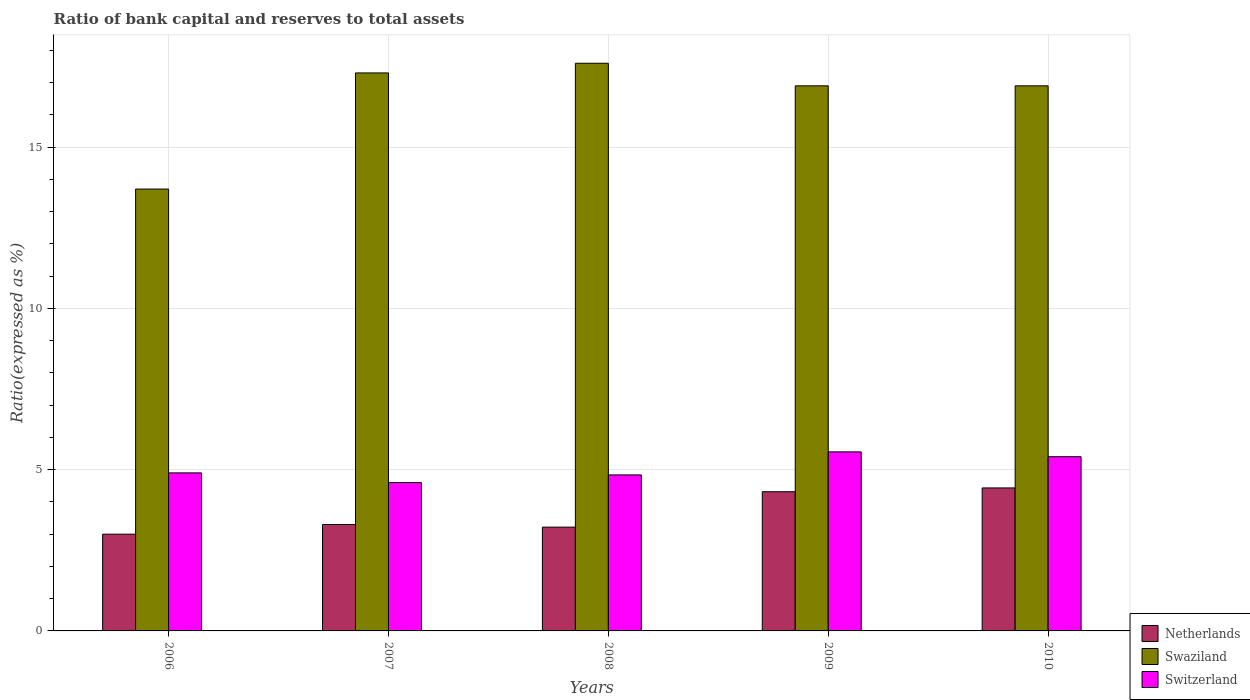Are the number of bars per tick equal to the number of legend labels?
Your answer should be compact. Yes. Are the number of bars on each tick of the X-axis equal?
Offer a terse response. Yes. What is the ratio of bank capital and reserves to total assets in Switzerland in 2008?
Ensure brevity in your answer.  4.84. Across all years, what is the maximum ratio of bank capital and reserves to total assets in Netherlands?
Provide a short and direct response. 4.43. Across all years, what is the minimum ratio of bank capital and reserves to total assets in Switzerland?
Keep it short and to the point. 4.6. In which year was the ratio of bank capital and reserves to total assets in Switzerland maximum?
Provide a succinct answer. 2009. In which year was the ratio of bank capital and reserves to total assets in Swaziland minimum?
Provide a short and direct response. 2006. What is the total ratio of bank capital and reserves to total assets in Swaziland in the graph?
Offer a very short reply. 82.4. What is the difference between the ratio of bank capital and reserves to total assets in Swaziland in 2008 and that in 2010?
Ensure brevity in your answer.  0.7. What is the difference between the ratio of bank capital and reserves to total assets in Switzerland in 2007 and the ratio of bank capital and reserves to total assets in Netherlands in 2006?
Give a very brief answer. 1.6. What is the average ratio of bank capital and reserves to total assets in Switzerland per year?
Your answer should be compact. 5.06. In the year 2009, what is the difference between the ratio of bank capital and reserves to total assets in Netherlands and ratio of bank capital and reserves to total assets in Switzerland?
Keep it short and to the point. -1.24. In how many years, is the ratio of bank capital and reserves to total assets in Netherlands greater than 4 %?
Your answer should be compact. 2. What is the ratio of the ratio of bank capital and reserves to total assets in Swaziland in 2007 to that in 2010?
Ensure brevity in your answer.  1.02. Is the ratio of bank capital and reserves to total assets in Netherlands in 2007 less than that in 2010?
Provide a short and direct response. Yes. What is the difference between the highest and the second highest ratio of bank capital and reserves to total assets in Swaziland?
Your answer should be very brief. 0.3. What is the difference between the highest and the lowest ratio of bank capital and reserves to total assets in Netherlands?
Ensure brevity in your answer.  1.43. Is the sum of the ratio of bank capital and reserves to total assets in Netherlands in 2009 and 2010 greater than the maximum ratio of bank capital and reserves to total assets in Switzerland across all years?
Provide a short and direct response. Yes. What does the 1st bar from the left in 2006 represents?
Your answer should be compact. Netherlands. What does the 2nd bar from the right in 2010 represents?
Provide a short and direct response. Swaziland. Is it the case that in every year, the sum of the ratio of bank capital and reserves to total assets in Switzerland and ratio of bank capital and reserves to total assets in Swaziland is greater than the ratio of bank capital and reserves to total assets in Netherlands?
Your answer should be compact. Yes. How many bars are there?
Provide a short and direct response. 15. Are the values on the major ticks of Y-axis written in scientific E-notation?
Offer a terse response. No. Does the graph contain grids?
Offer a very short reply. Yes. Where does the legend appear in the graph?
Offer a terse response. Bottom right. What is the title of the graph?
Keep it short and to the point. Ratio of bank capital and reserves to total assets. Does "Central African Republic" appear as one of the legend labels in the graph?
Offer a terse response. No. What is the label or title of the Y-axis?
Offer a very short reply. Ratio(expressed as %). What is the Ratio(expressed as %) in Swaziland in 2007?
Your response must be concise. 17.3. What is the Ratio(expressed as %) in Netherlands in 2008?
Your answer should be compact. 3.22. What is the Ratio(expressed as %) of Swaziland in 2008?
Keep it short and to the point. 17.6. What is the Ratio(expressed as %) of Switzerland in 2008?
Offer a very short reply. 4.84. What is the Ratio(expressed as %) of Netherlands in 2009?
Provide a succinct answer. 4.32. What is the Ratio(expressed as %) in Swaziland in 2009?
Offer a terse response. 16.9. What is the Ratio(expressed as %) in Switzerland in 2009?
Your answer should be very brief. 5.55. What is the Ratio(expressed as %) in Netherlands in 2010?
Provide a succinct answer. 4.43. What is the Ratio(expressed as %) of Switzerland in 2010?
Provide a succinct answer. 5.4. Across all years, what is the maximum Ratio(expressed as %) of Netherlands?
Your answer should be very brief. 4.43. Across all years, what is the maximum Ratio(expressed as %) in Switzerland?
Provide a short and direct response. 5.55. Across all years, what is the minimum Ratio(expressed as %) in Netherlands?
Your answer should be very brief. 3. What is the total Ratio(expressed as %) of Netherlands in the graph?
Offer a very short reply. 18.27. What is the total Ratio(expressed as %) of Swaziland in the graph?
Keep it short and to the point. 82.4. What is the total Ratio(expressed as %) in Switzerland in the graph?
Provide a succinct answer. 25.29. What is the difference between the Ratio(expressed as %) in Netherlands in 2006 and that in 2007?
Your answer should be compact. -0.3. What is the difference between the Ratio(expressed as %) in Netherlands in 2006 and that in 2008?
Your response must be concise. -0.22. What is the difference between the Ratio(expressed as %) in Switzerland in 2006 and that in 2008?
Your answer should be compact. 0.06. What is the difference between the Ratio(expressed as %) of Netherlands in 2006 and that in 2009?
Your answer should be compact. -1.32. What is the difference between the Ratio(expressed as %) in Switzerland in 2006 and that in 2009?
Offer a very short reply. -0.65. What is the difference between the Ratio(expressed as %) of Netherlands in 2006 and that in 2010?
Give a very brief answer. -1.43. What is the difference between the Ratio(expressed as %) of Switzerland in 2006 and that in 2010?
Your answer should be compact. -0.5. What is the difference between the Ratio(expressed as %) in Netherlands in 2007 and that in 2008?
Your response must be concise. 0.08. What is the difference between the Ratio(expressed as %) of Switzerland in 2007 and that in 2008?
Your answer should be compact. -0.24. What is the difference between the Ratio(expressed as %) of Netherlands in 2007 and that in 2009?
Offer a very short reply. -1.02. What is the difference between the Ratio(expressed as %) of Switzerland in 2007 and that in 2009?
Provide a succinct answer. -0.95. What is the difference between the Ratio(expressed as %) in Netherlands in 2007 and that in 2010?
Your answer should be compact. -1.13. What is the difference between the Ratio(expressed as %) in Switzerland in 2007 and that in 2010?
Give a very brief answer. -0.8. What is the difference between the Ratio(expressed as %) of Netherlands in 2008 and that in 2009?
Your answer should be very brief. -1.1. What is the difference between the Ratio(expressed as %) in Switzerland in 2008 and that in 2009?
Provide a succinct answer. -0.71. What is the difference between the Ratio(expressed as %) of Netherlands in 2008 and that in 2010?
Your response must be concise. -1.22. What is the difference between the Ratio(expressed as %) of Swaziland in 2008 and that in 2010?
Your response must be concise. 0.7. What is the difference between the Ratio(expressed as %) of Switzerland in 2008 and that in 2010?
Offer a very short reply. -0.56. What is the difference between the Ratio(expressed as %) of Netherlands in 2009 and that in 2010?
Offer a very short reply. -0.12. What is the difference between the Ratio(expressed as %) of Swaziland in 2009 and that in 2010?
Give a very brief answer. 0. What is the difference between the Ratio(expressed as %) of Switzerland in 2009 and that in 2010?
Offer a terse response. 0.15. What is the difference between the Ratio(expressed as %) of Netherlands in 2006 and the Ratio(expressed as %) of Swaziland in 2007?
Your answer should be compact. -14.3. What is the difference between the Ratio(expressed as %) of Netherlands in 2006 and the Ratio(expressed as %) of Switzerland in 2007?
Offer a very short reply. -1.6. What is the difference between the Ratio(expressed as %) in Netherlands in 2006 and the Ratio(expressed as %) in Swaziland in 2008?
Give a very brief answer. -14.6. What is the difference between the Ratio(expressed as %) in Netherlands in 2006 and the Ratio(expressed as %) in Switzerland in 2008?
Give a very brief answer. -1.84. What is the difference between the Ratio(expressed as %) of Swaziland in 2006 and the Ratio(expressed as %) of Switzerland in 2008?
Give a very brief answer. 8.86. What is the difference between the Ratio(expressed as %) in Netherlands in 2006 and the Ratio(expressed as %) in Switzerland in 2009?
Offer a terse response. -2.55. What is the difference between the Ratio(expressed as %) of Swaziland in 2006 and the Ratio(expressed as %) of Switzerland in 2009?
Provide a short and direct response. 8.15. What is the difference between the Ratio(expressed as %) in Netherlands in 2006 and the Ratio(expressed as %) in Switzerland in 2010?
Provide a succinct answer. -2.4. What is the difference between the Ratio(expressed as %) of Swaziland in 2006 and the Ratio(expressed as %) of Switzerland in 2010?
Your answer should be very brief. 8.3. What is the difference between the Ratio(expressed as %) of Netherlands in 2007 and the Ratio(expressed as %) of Swaziland in 2008?
Provide a short and direct response. -14.3. What is the difference between the Ratio(expressed as %) in Netherlands in 2007 and the Ratio(expressed as %) in Switzerland in 2008?
Give a very brief answer. -1.54. What is the difference between the Ratio(expressed as %) of Swaziland in 2007 and the Ratio(expressed as %) of Switzerland in 2008?
Give a very brief answer. 12.46. What is the difference between the Ratio(expressed as %) in Netherlands in 2007 and the Ratio(expressed as %) in Swaziland in 2009?
Provide a succinct answer. -13.6. What is the difference between the Ratio(expressed as %) of Netherlands in 2007 and the Ratio(expressed as %) of Switzerland in 2009?
Provide a succinct answer. -2.25. What is the difference between the Ratio(expressed as %) of Swaziland in 2007 and the Ratio(expressed as %) of Switzerland in 2009?
Make the answer very short. 11.75. What is the difference between the Ratio(expressed as %) in Netherlands in 2007 and the Ratio(expressed as %) in Swaziland in 2010?
Provide a short and direct response. -13.6. What is the difference between the Ratio(expressed as %) in Netherlands in 2007 and the Ratio(expressed as %) in Switzerland in 2010?
Keep it short and to the point. -2.1. What is the difference between the Ratio(expressed as %) of Swaziland in 2007 and the Ratio(expressed as %) of Switzerland in 2010?
Make the answer very short. 11.9. What is the difference between the Ratio(expressed as %) in Netherlands in 2008 and the Ratio(expressed as %) in Swaziland in 2009?
Provide a succinct answer. -13.68. What is the difference between the Ratio(expressed as %) of Netherlands in 2008 and the Ratio(expressed as %) of Switzerland in 2009?
Your response must be concise. -2.33. What is the difference between the Ratio(expressed as %) of Swaziland in 2008 and the Ratio(expressed as %) of Switzerland in 2009?
Make the answer very short. 12.05. What is the difference between the Ratio(expressed as %) in Netherlands in 2008 and the Ratio(expressed as %) in Swaziland in 2010?
Your response must be concise. -13.68. What is the difference between the Ratio(expressed as %) in Netherlands in 2008 and the Ratio(expressed as %) in Switzerland in 2010?
Keep it short and to the point. -2.18. What is the difference between the Ratio(expressed as %) in Swaziland in 2008 and the Ratio(expressed as %) in Switzerland in 2010?
Provide a short and direct response. 12.2. What is the difference between the Ratio(expressed as %) in Netherlands in 2009 and the Ratio(expressed as %) in Swaziland in 2010?
Offer a very short reply. -12.58. What is the difference between the Ratio(expressed as %) of Netherlands in 2009 and the Ratio(expressed as %) of Switzerland in 2010?
Give a very brief answer. -1.09. What is the difference between the Ratio(expressed as %) of Swaziland in 2009 and the Ratio(expressed as %) of Switzerland in 2010?
Give a very brief answer. 11.5. What is the average Ratio(expressed as %) in Netherlands per year?
Provide a succinct answer. 3.65. What is the average Ratio(expressed as %) in Swaziland per year?
Make the answer very short. 16.48. What is the average Ratio(expressed as %) in Switzerland per year?
Offer a very short reply. 5.06. In the year 2007, what is the difference between the Ratio(expressed as %) in Netherlands and Ratio(expressed as %) in Switzerland?
Your answer should be compact. -1.3. In the year 2008, what is the difference between the Ratio(expressed as %) in Netherlands and Ratio(expressed as %) in Swaziland?
Offer a terse response. -14.38. In the year 2008, what is the difference between the Ratio(expressed as %) in Netherlands and Ratio(expressed as %) in Switzerland?
Provide a short and direct response. -1.62. In the year 2008, what is the difference between the Ratio(expressed as %) in Swaziland and Ratio(expressed as %) in Switzerland?
Ensure brevity in your answer.  12.76. In the year 2009, what is the difference between the Ratio(expressed as %) in Netherlands and Ratio(expressed as %) in Swaziland?
Make the answer very short. -12.58. In the year 2009, what is the difference between the Ratio(expressed as %) of Netherlands and Ratio(expressed as %) of Switzerland?
Your answer should be very brief. -1.24. In the year 2009, what is the difference between the Ratio(expressed as %) in Swaziland and Ratio(expressed as %) in Switzerland?
Provide a short and direct response. 11.35. In the year 2010, what is the difference between the Ratio(expressed as %) in Netherlands and Ratio(expressed as %) in Swaziland?
Your answer should be very brief. -12.47. In the year 2010, what is the difference between the Ratio(expressed as %) in Netherlands and Ratio(expressed as %) in Switzerland?
Provide a short and direct response. -0.97. In the year 2010, what is the difference between the Ratio(expressed as %) in Swaziland and Ratio(expressed as %) in Switzerland?
Ensure brevity in your answer.  11.5. What is the ratio of the Ratio(expressed as %) of Swaziland in 2006 to that in 2007?
Give a very brief answer. 0.79. What is the ratio of the Ratio(expressed as %) in Switzerland in 2006 to that in 2007?
Ensure brevity in your answer.  1.07. What is the ratio of the Ratio(expressed as %) of Netherlands in 2006 to that in 2008?
Your answer should be very brief. 0.93. What is the ratio of the Ratio(expressed as %) in Swaziland in 2006 to that in 2008?
Your answer should be very brief. 0.78. What is the ratio of the Ratio(expressed as %) in Switzerland in 2006 to that in 2008?
Provide a short and direct response. 1.01. What is the ratio of the Ratio(expressed as %) in Netherlands in 2006 to that in 2009?
Your response must be concise. 0.7. What is the ratio of the Ratio(expressed as %) of Swaziland in 2006 to that in 2009?
Offer a very short reply. 0.81. What is the ratio of the Ratio(expressed as %) in Switzerland in 2006 to that in 2009?
Your answer should be very brief. 0.88. What is the ratio of the Ratio(expressed as %) in Netherlands in 2006 to that in 2010?
Ensure brevity in your answer.  0.68. What is the ratio of the Ratio(expressed as %) of Swaziland in 2006 to that in 2010?
Offer a very short reply. 0.81. What is the ratio of the Ratio(expressed as %) in Switzerland in 2006 to that in 2010?
Your answer should be very brief. 0.91. What is the ratio of the Ratio(expressed as %) of Netherlands in 2007 to that in 2008?
Provide a succinct answer. 1.03. What is the ratio of the Ratio(expressed as %) in Swaziland in 2007 to that in 2008?
Provide a short and direct response. 0.98. What is the ratio of the Ratio(expressed as %) of Switzerland in 2007 to that in 2008?
Your answer should be compact. 0.95. What is the ratio of the Ratio(expressed as %) in Netherlands in 2007 to that in 2009?
Give a very brief answer. 0.76. What is the ratio of the Ratio(expressed as %) in Swaziland in 2007 to that in 2009?
Provide a succinct answer. 1.02. What is the ratio of the Ratio(expressed as %) of Switzerland in 2007 to that in 2009?
Your answer should be compact. 0.83. What is the ratio of the Ratio(expressed as %) in Netherlands in 2007 to that in 2010?
Your answer should be very brief. 0.74. What is the ratio of the Ratio(expressed as %) of Swaziland in 2007 to that in 2010?
Your answer should be compact. 1.02. What is the ratio of the Ratio(expressed as %) of Switzerland in 2007 to that in 2010?
Make the answer very short. 0.85. What is the ratio of the Ratio(expressed as %) in Netherlands in 2008 to that in 2009?
Your answer should be compact. 0.75. What is the ratio of the Ratio(expressed as %) in Swaziland in 2008 to that in 2009?
Offer a very short reply. 1.04. What is the ratio of the Ratio(expressed as %) in Switzerland in 2008 to that in 2009?
Provide a short and direct response. 0.87. What is the ratio of the Ratio(expressed as %) in Netherlands in 2008 to that in 2010?
Provide a succinct answer. 0.73. What is the ratio of the Ratio(expressed as %) in Swaziland in 2008 to that in 2010?
Your answer should be compact. 1.04. What is the ratio of the Ratio(expressed as %) of Switzerland in 2008 to that in 2010?
Provide a short and direct response. 0.9. What is the ratio of the Ratio(expressed as %) of Netherlands in 2009 to that in 2010?
Give a very brief answer. 0.97. What is the ratio of the Ratio(expressed as %) of Swaziland in 2009 to that in 2010?
Offer a terse response. 1. What is the ratio of the Ratio(expressed as %) of Switzerland in 2009 to that in 2010?
Offer a terse response. 1.03. What is the difference between the highest and the second highest Ratio(expressed as %) in Netherlands?
Give a very brief answer. 0.12. What is the difference between the highest and the second highest Ratio(expressed as %) of Switzerland?
Provide a succinct answer. 0.15. What is the difference between the highest and the lowest Ratio(expressed as %) of Netherlands?
Keep it short and to the point. 1.43. What is the difference between the highest and the lowest Ratio(expressed as %) of Swaziland?
Provide a short and direct response. 3.9. What is the difference between the highest and the lowest Ratio(expressed as %) in Switzerland?
Provide a short and direct response. 0.95. 